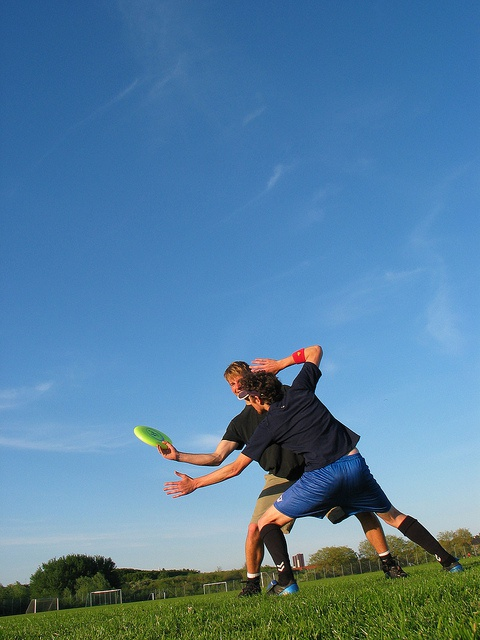Describe the objects in this image and their specific colors. I can see people in blue, black, salmon, and navy tones, people in blue, black, tan, maroon, and brown tones, and frisbee in blue, green, khaki, lightgreen, and olive tones in this image. 